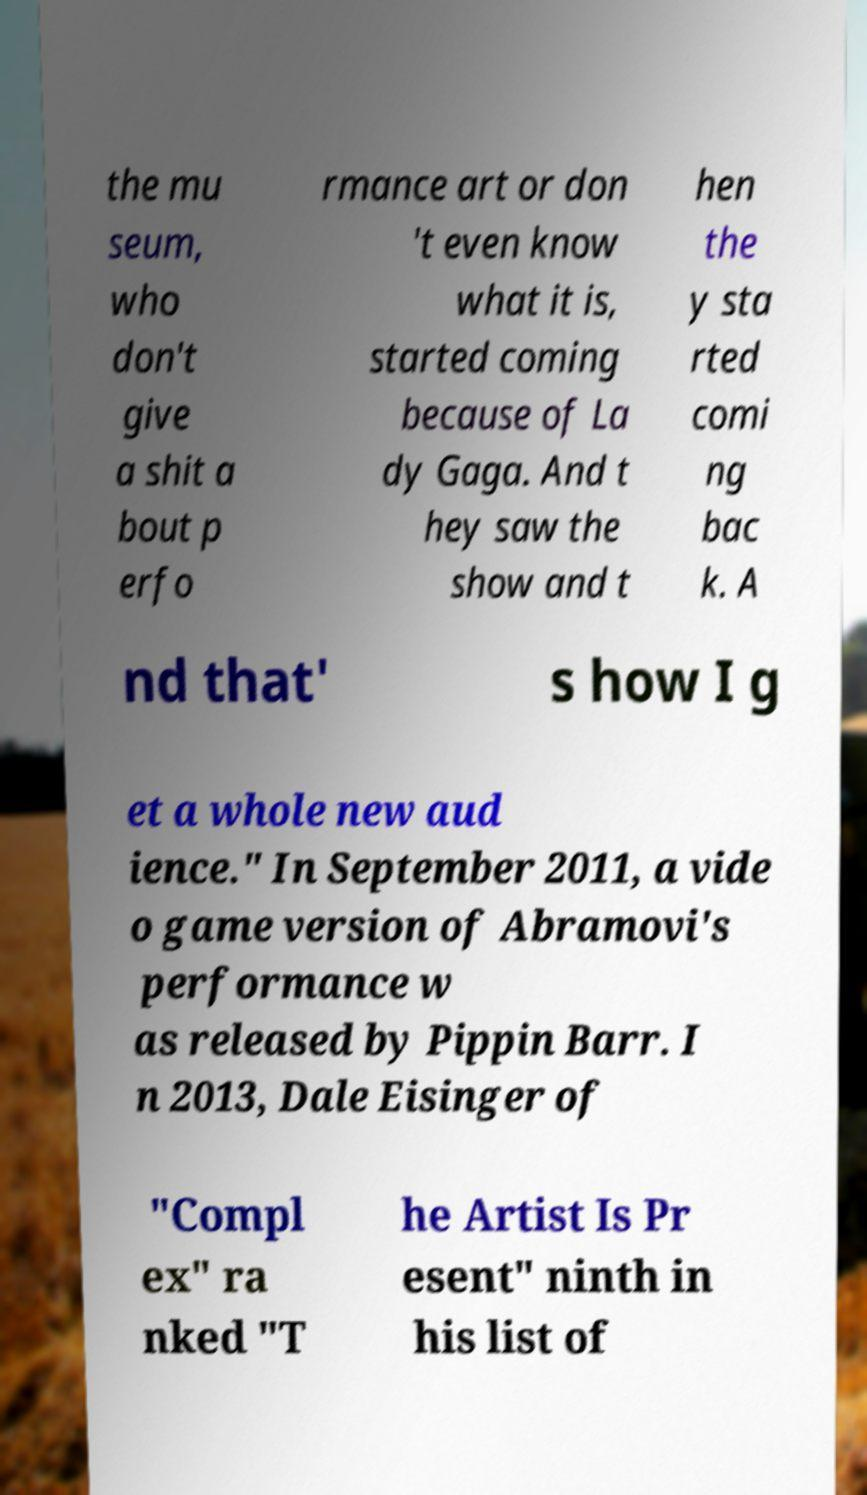I need the written content from this picture converted into text. Can you do that? the mu seum, who don't give a shit a bout p erfo rmance art or don 't even know what it is, started coming because of La dy Gaga. And t hey saw the show and t hen the y sta rted comi ng bac k. A nd that' s how I g et a whole new aud ience." In September 2011, a vide o game version of Abramovi's performance w as released by Pippin Barr. I n 2013, Dale Eisinger of "Compl ex" ra nked "T he Artist Is Pr esent" ninth in his list of 